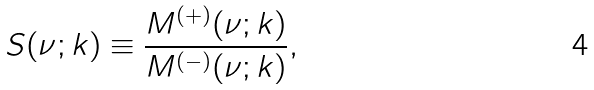Convert formula to latex. <formula><loc_0><loc_0><loc_500><loc_500>S ( \nu ; k ) \equiv \frac { M ^ { ( + ) } ( \nu ; k ) } { M ^ { ( - ) } ( \nu ; k ) } ,</formula> 